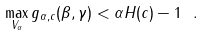<formula> <loc_0><loc_0><loc_500><loc_500>\max _ { V _ { \alpha } } g _ { \alpha , c } ( \beta , \gamma ) < \alpha H ( c ) - 1 \ .</formula> 